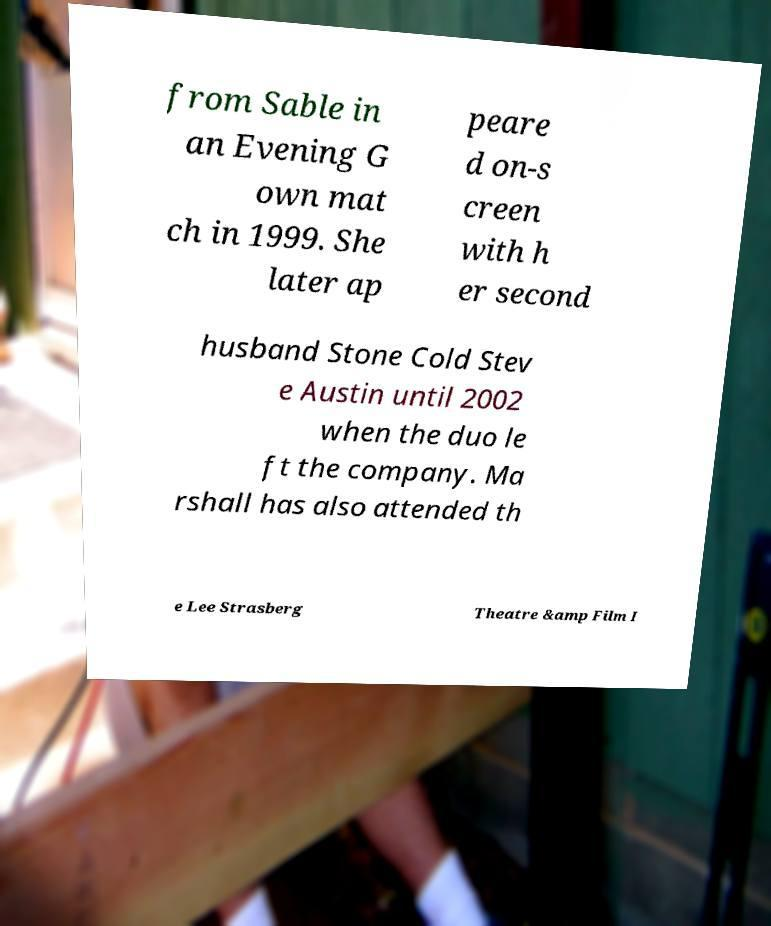Can you read and provide the text displayed in the image?This photo seems to have some interesting text. Can you extract and type it out for me? from Sable in an Evening G own mat ch in 1999. She later ap peare d on-s creen with h er second husband Stone Cold Stev e Austin until 2002 when the duo le ft the company. Ma rshall has also attended th e Lee Strasberg Theatre &amp Film I 